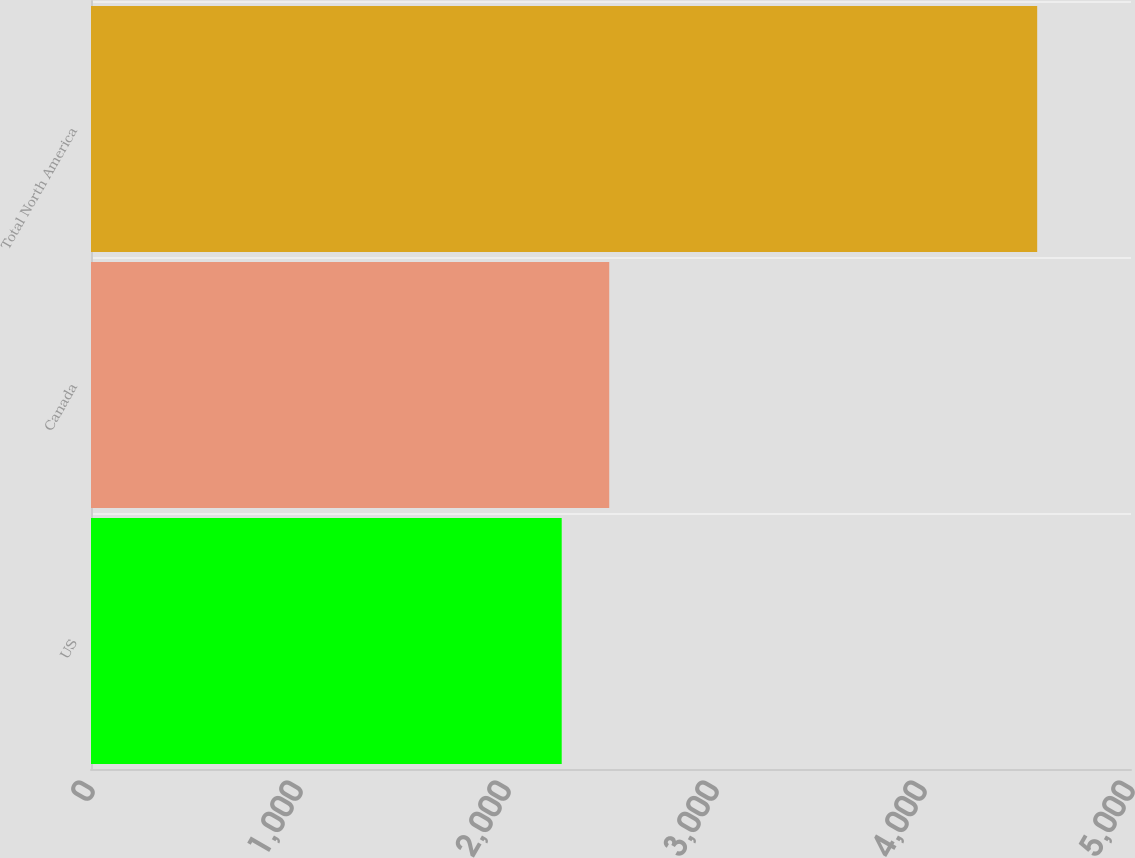Convert chart. <chart><loc_0><loc_0><loc_500><loc_500><bar_chart><fcel>US<fcel>Canada<fcel>Total North America<nl><fcel>2263<fcel>2491.6<fcel>4549<nl></chart> 